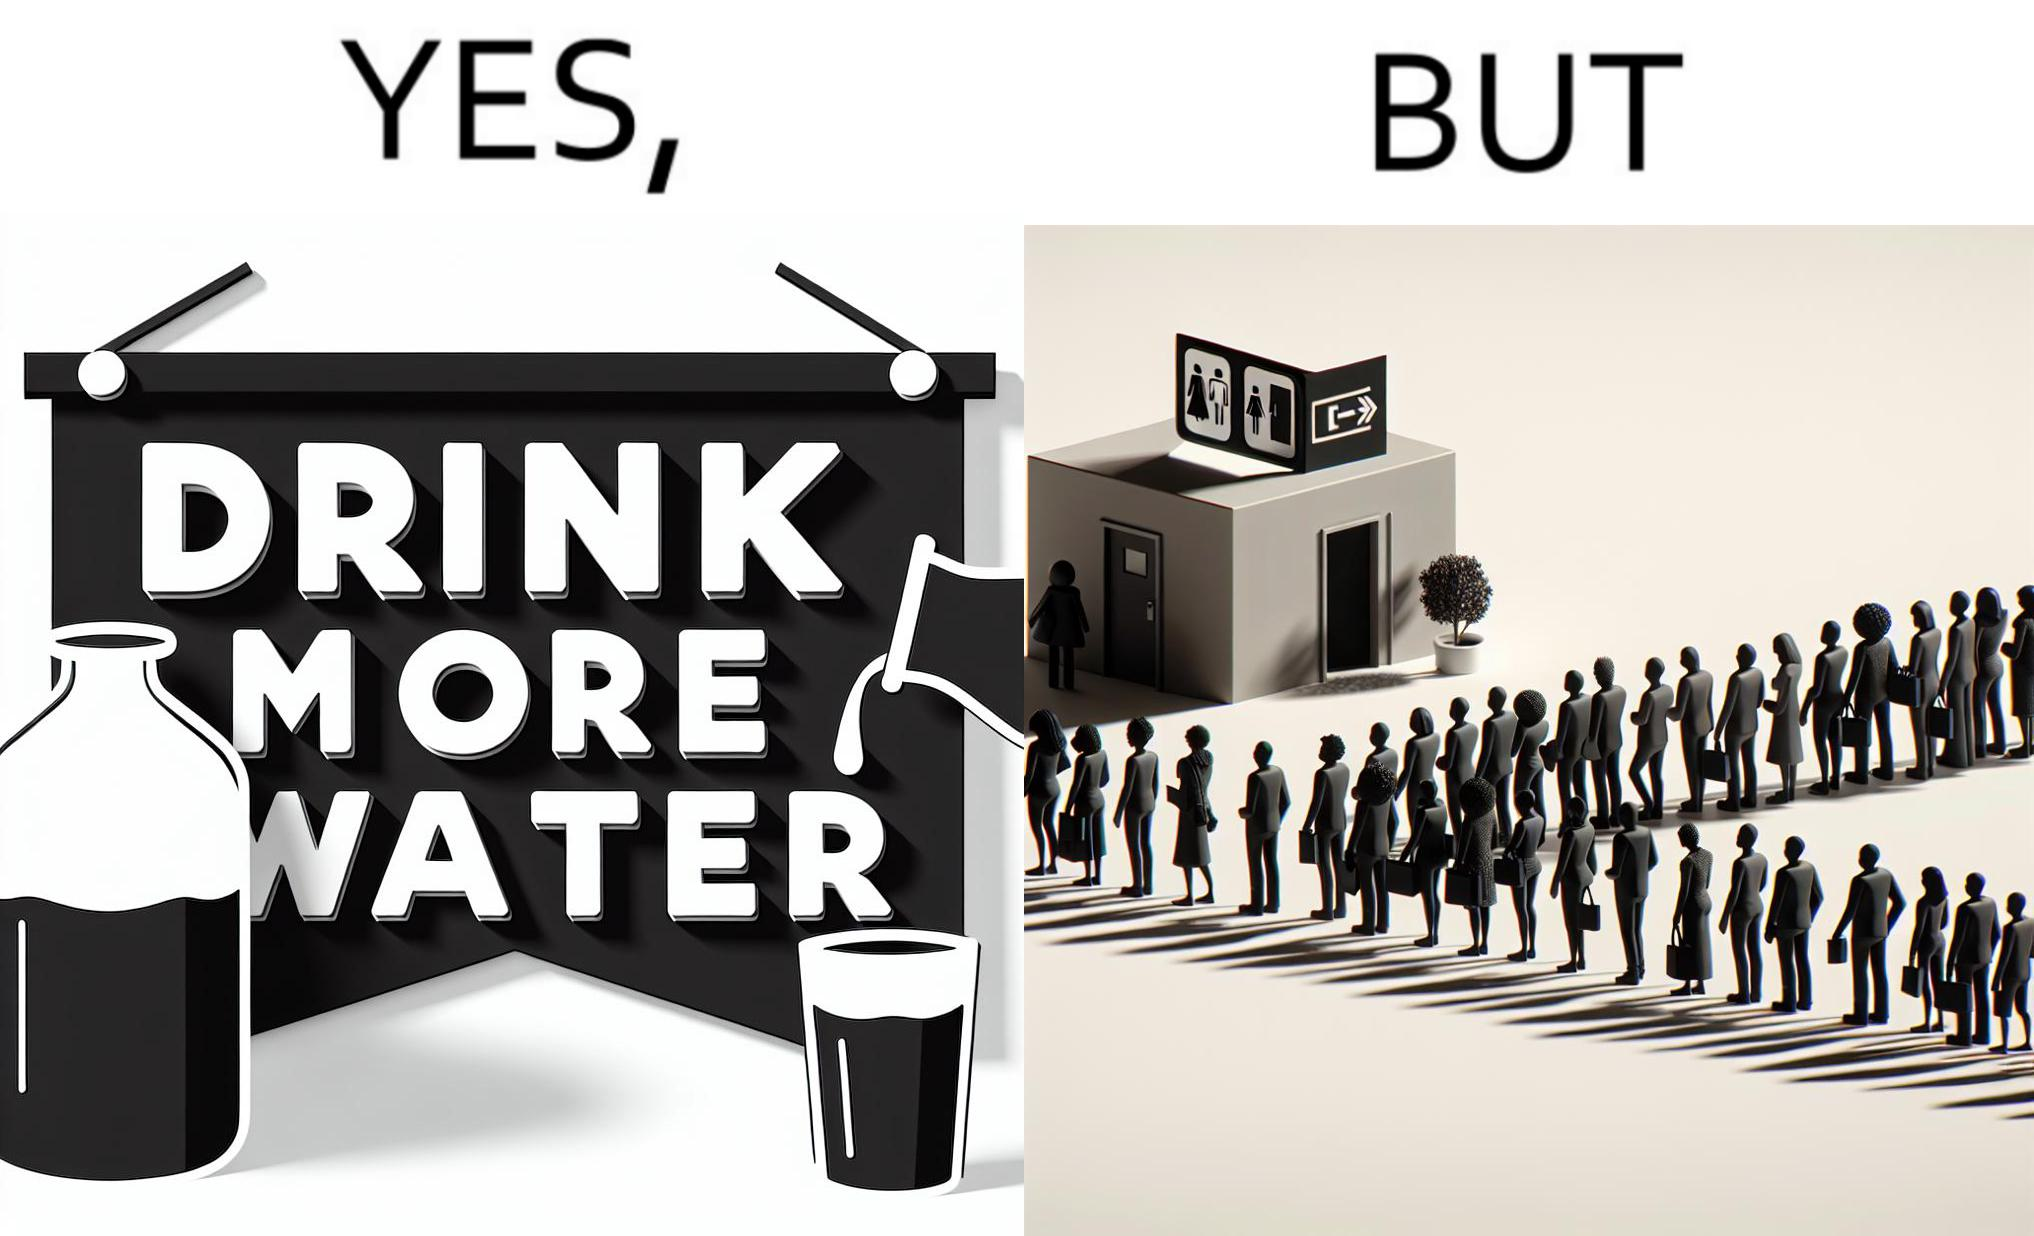Describe the content of this image. The image is ironical, as the message "Drink more water" is meant to improve health, but in turn, it would lead to longer queues in front of public toilets, leading to people holding urine for longer periods, in turn leading to deterioration in health. 